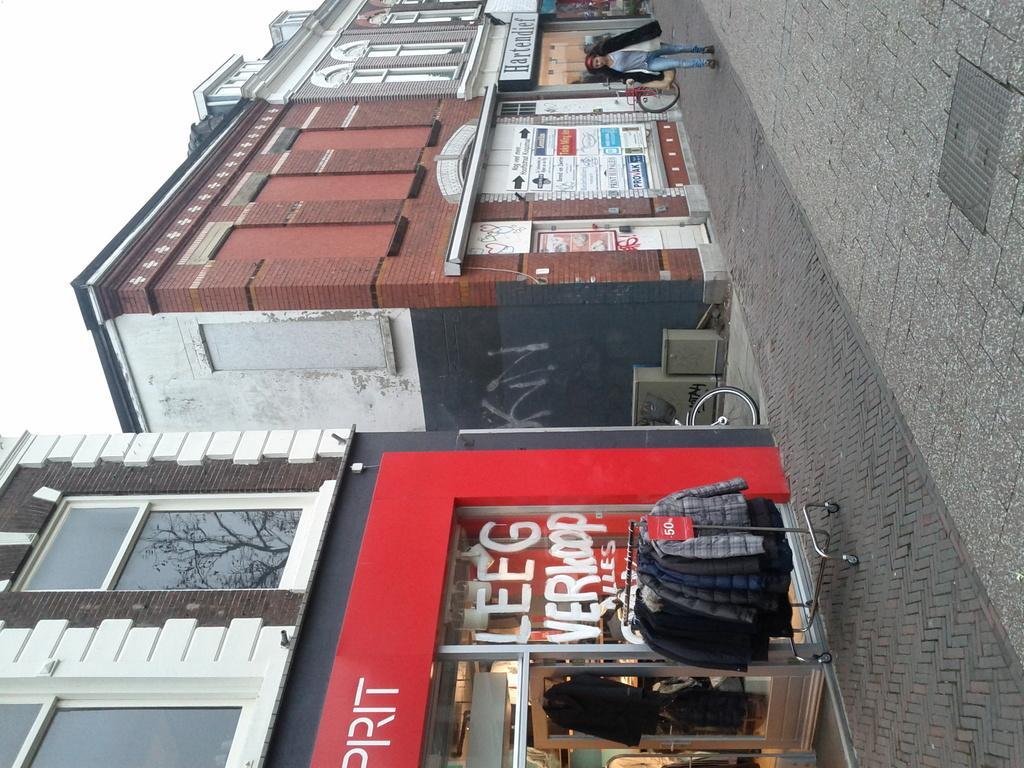How would you summarize this image in a sentence or two? In this image we can see a woman standing on the ground, group of clothes placed on stands, group of buildings with windows, sign boards with text, bicycle placed on the ground. In the background, we can see some boxes and the sky. 